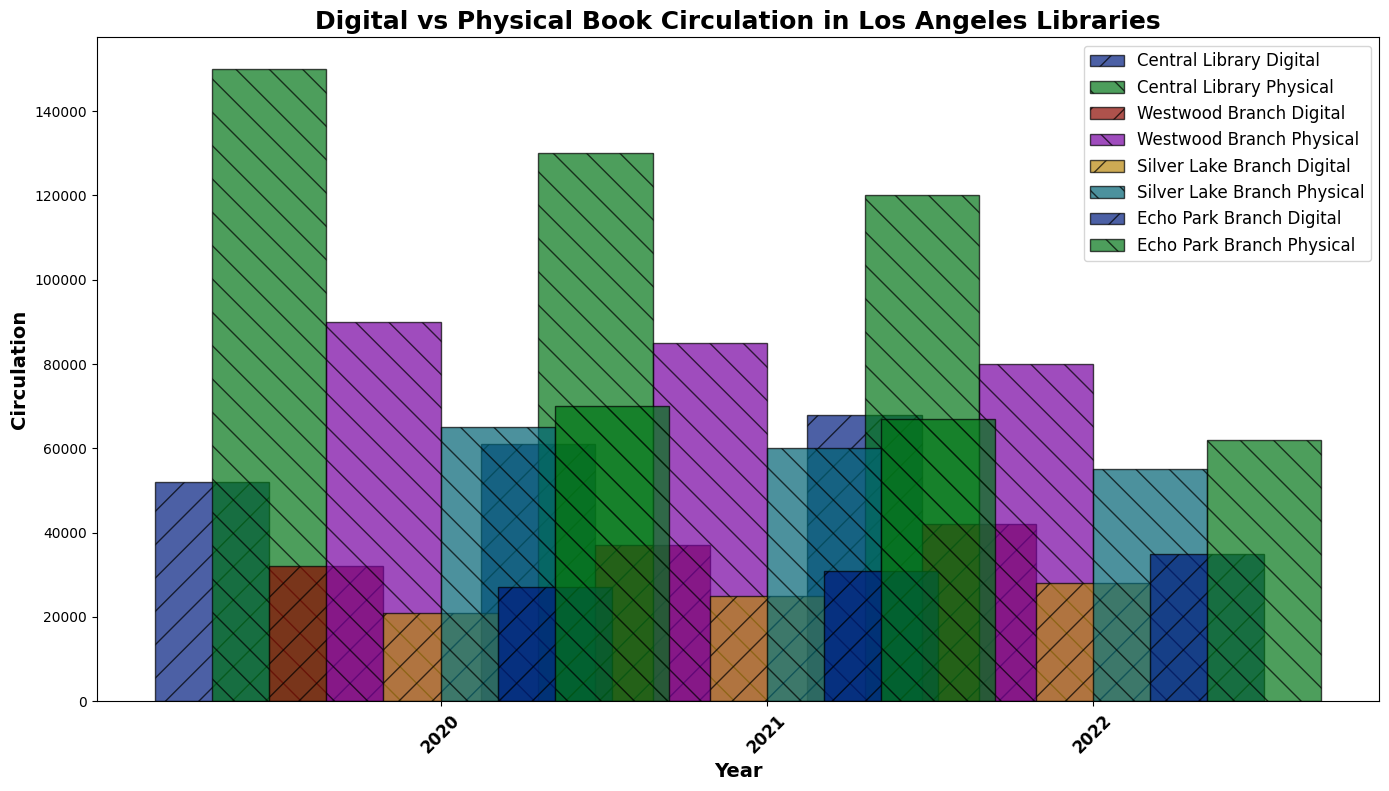Which library had the highest digital book circulation in 2022? Compare the height of the bars for digital book circulation for each library in 2022. The tallest bar represents Central Library.
Answer: Central Library How did the physical book circulation trend for the Westwood Branch from 2020 to 2022? Observe the physical book bars for Westwood Branch from 2020 to 2022. They consistently decrease from 90000 in 2020 to 85000 in 2021 to 80000 in 2022.
Answer: Decreasing In 2021, how did Silver Lake Branch's digital book circulation compare to Echo Park Branch's digital book circulation? Compare the height of the bars for Silver Lake Branch and Echo Park Branch in 2021 for digital books. The bar for Echo Park Branch is higher than Silver Lake Branch by 6000 (31000 vs. 25000).
Answer: Echo Park Branch was higher What was the total digital book circulation for Central Library over the three years? Sum the values for digital book circulation for Central Library for 2020, 2021, and 2022 (52000 + 61000 + 68000).
Answer: 181000 Which year had the highest overall physical book circulation across all libraries? Sum the physical book circulation of all libraries for each year: 150000+90000+65000+70000 for 2020, 130000+85000+60000+67000 for 2021, and 120000+80000+55000+62000 for 2022. The highest sum is in 2020.
Answer: 2020 What was the average digital book circulation for Echo Park Branch from 2020 to 2022? Sum the values for Echo Park Branch's digital book circulation for 2020, 2021, and 2022 (27000 + 31000 + 35000). Divide the total by 3.
Answer: 31000 By how much did Central Library's physical book circulation decrease from 2020 to 2021? Subtract the physical book circulation for Central Library in 2021 from that in 2020 (150000 - 130000).
Answer: 20000 Which library showed a consistent increase in digital book circulation from 2020 to 2022? Observe the bars for digital book circulation from 2020 to 2022 for each library. Central Library, Westwood Branch, Silver Lake Branch, and Echo Park Branch all show increasing trends, but the exact library must be cross-checked.
Answer: All libraries How did the digital book circulation compare to physical book circulation for Central Library in 2022? Compare the heights of the digital and physical book bars for Central Library in 2022. The physical book bar is visibly taller than the digital book bar (120000 to 68000).
Answer: Physical books were higher 